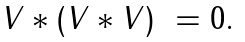<formula> <loc_0><loc_0><loc_500><loc_500>\begin{array} { l } V \ast ( V \ast V ) \ = 0 . \\ \end{array}</formula> 